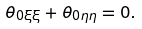<formula> <loc_0><loc_0><loc_500><loc_500>\theta _ { 0 \xi \xi } + \theta _ { 0 \eta \eta } = 0 .</formula> 